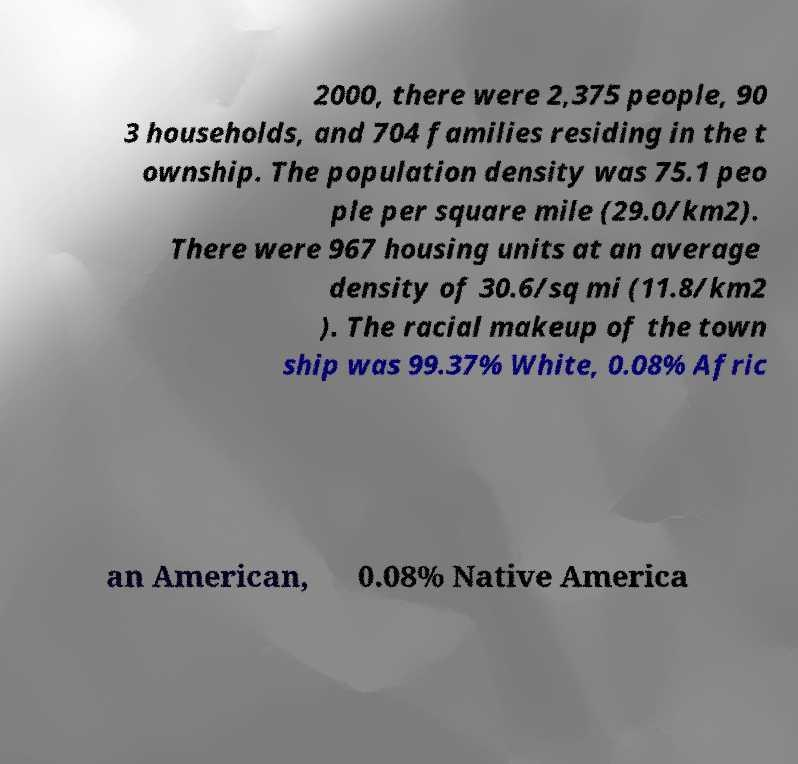Can you read and provide the text displayed in the image?This photo seems to have some interesting text. Can you extract and type it out for me? 2000, there were 2,375 people, 90 3 households, and 704 families residing in the t ownship. The population density was 75.1 peo ple per square mile (29.0/km2). There were 967 housing units at an average density of 30.6/sq mi (11.8/km2 ). The racial makeup of the town ship was 99.37% White, 0.08% Afric an American, 0.08% Native America 